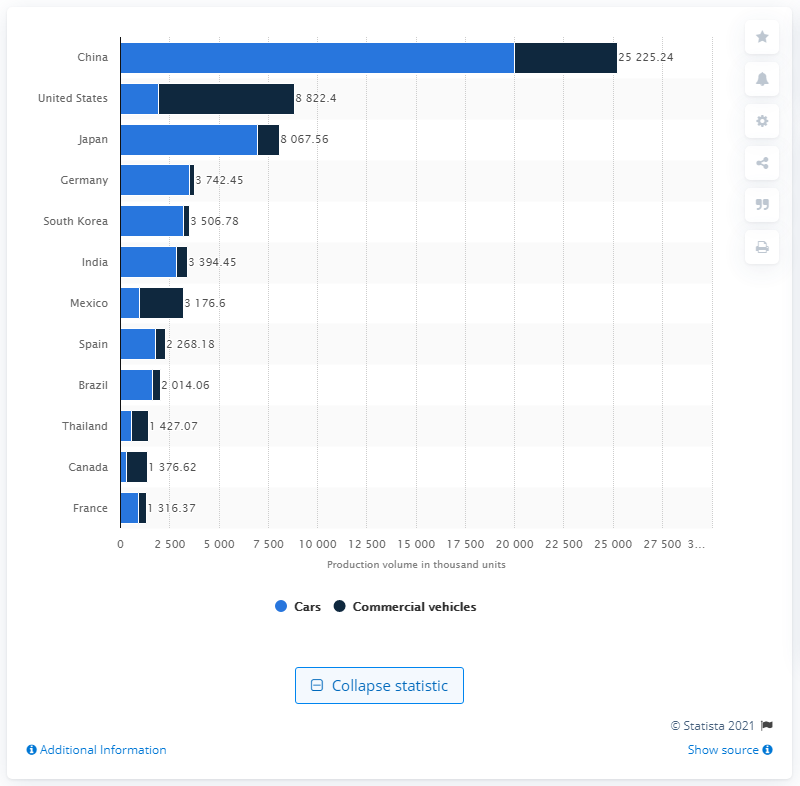Give some essential details in this illustration. China was the leading market for motor vehicle production in the year. 